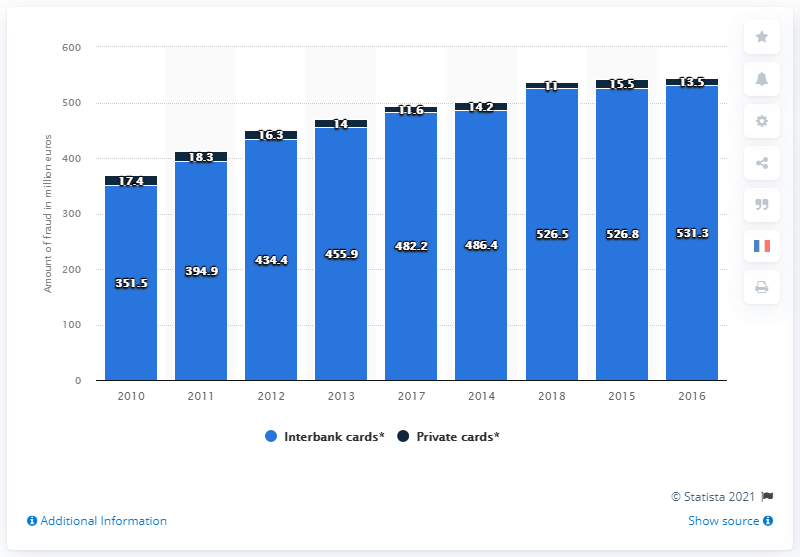Outline some significant characteristics in this image. In 2018, the value of fraud damage involving private type cards in France was approximately 11... 